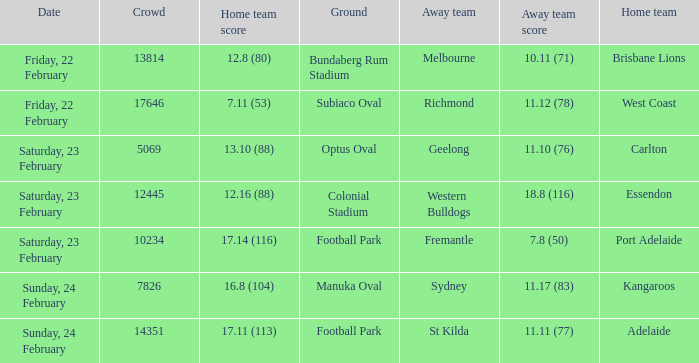On what date did the away team Fremantle play? Saturday, 23 February. Could you parse the entire table? {'header': ['Date', 'Crowd', 'Home team score', 'Ground', 'Away team', 'Away team score', 'Home team'], 'rows': [['Friday, 22 February', '13814', '12.8 (80)', 'Bundaberg Rum Stadium', 'Melbourne', '10.11 (71)', 'Brisbane Lions'], ['Friday, 22 February', '17646', '7.11 (53)', 'Subiaco Oval', 'Richmond', '11.12 (78)', 'West Coast'], ['Saturday, 23 February', '5069', '13.10 (88)', 'Optus Oval', 'Geelong', '11.10 (76)', 'Carlton'], ['Saturday, 23 February', '12445', '12.16 (88)', 'Colonial Stadium', 'Western Bulldogs', '18.8 (116)', 'Essendon'], ['Saturday, 23 February', '10234', '17.14 (116)', 'Football Park', 'Fremantle', '7.8 (50)', 'Port Adelaide'], ['Sunday, 24 February', '7826', '16.8 (104)', 'Manuka Oval', 'Sydney', '11.17 (83)', 'Kangaroos'], ['Sunday, 24 February', '14351', '17.11 (113)', 'Football Park', 'St Kilda', '11.11 (77)', 'Adelaide']]} 